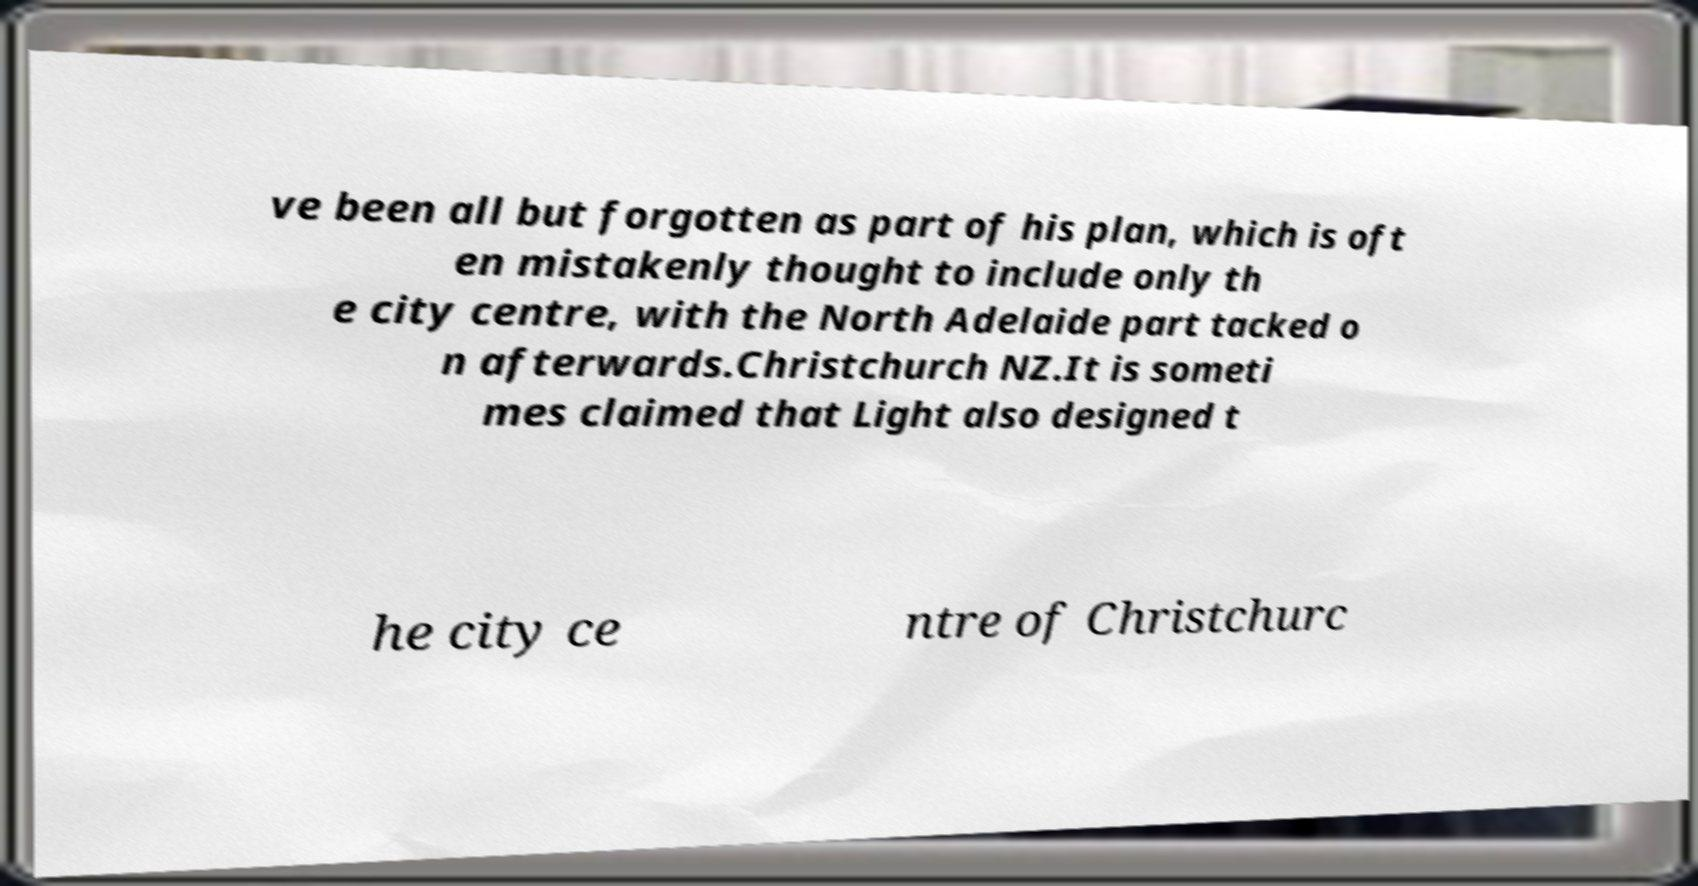What messages or text are displayed in this image? I need them in a readable, typed format. ve been all but forgotten as part of his plan, which is oft en mistakenly thought to include only th e city centre, with the North Adelaide part tacked o n afterwards.Christchurch NZ.It is someti mes claimed that Light also designed t he city ce ntre of Christchurc 